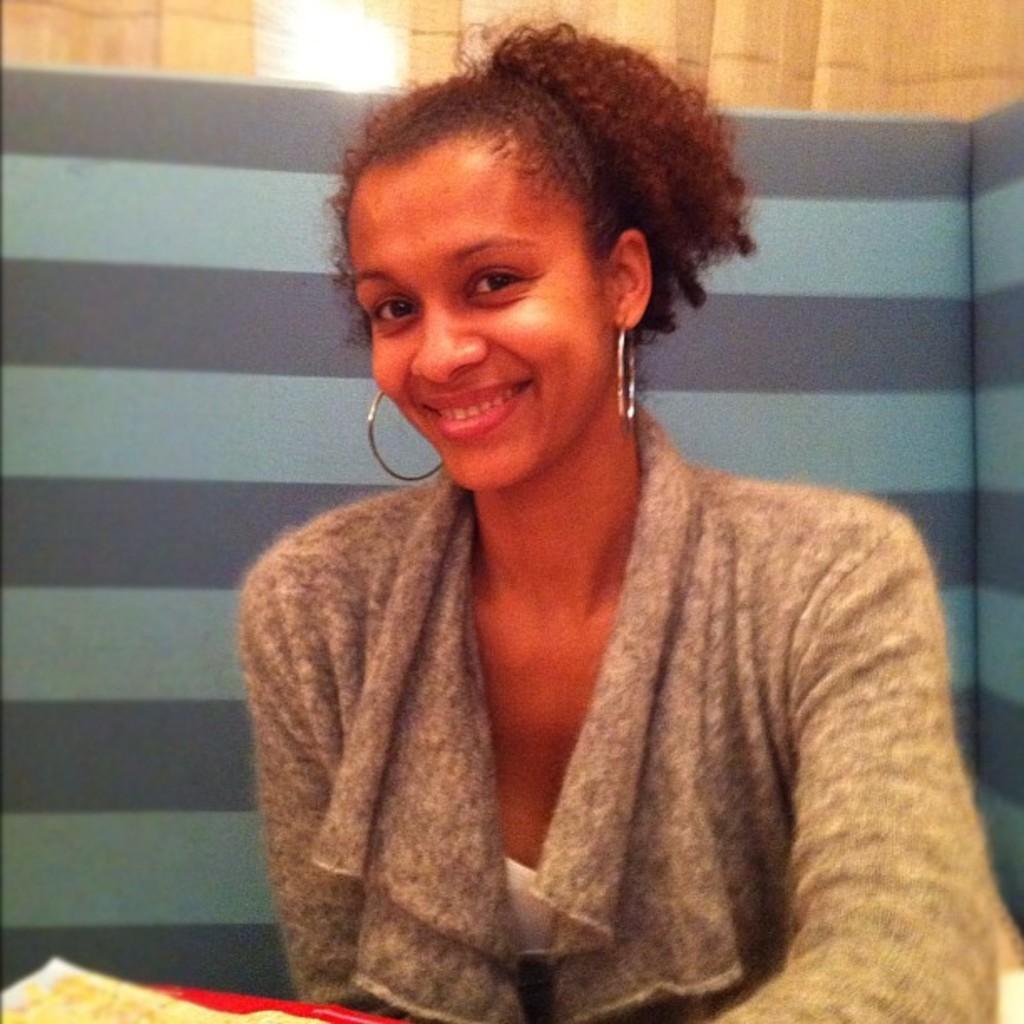Please provide a concise description of this image. In this picture we can see a woman is smiling. In front of the women there are some objects. Behind the woman, it looks like a board and a curtain. 